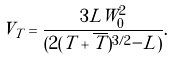Convert formula to latex. <formula><loc_0><loc_0><loc_500><loc_500>V _ { T } = \frac { 3 L W _ { 0 } ^ { 2 } } { ( 2 ( T + \overline { T } ) ^ { 3 / 2 } - L ) } .</formula> 